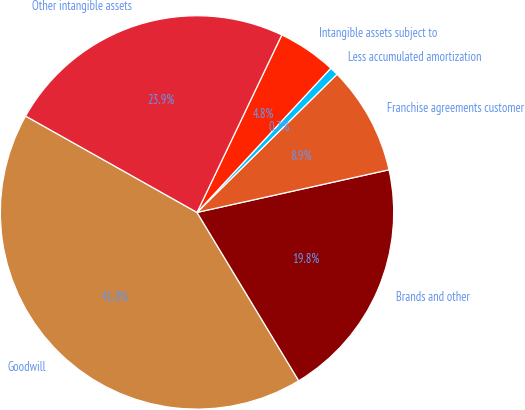Convert chart to OTSL. <chart><loc_0><loc_0><loc_500><loc_500><pie_chart><fcel>Goodwill<fcel>Brands and other<fcel>Franchise agreements customer<fcel>Less accumulated amortization<fcel>Intangible assets subject to<fcel>Other intangible assets<nl><fcel>41.8%<fcel>19.83%<fcel>8.92%<fcel>0.7%<fcel>4.81%<fcel>23.94%<nl></chart> 